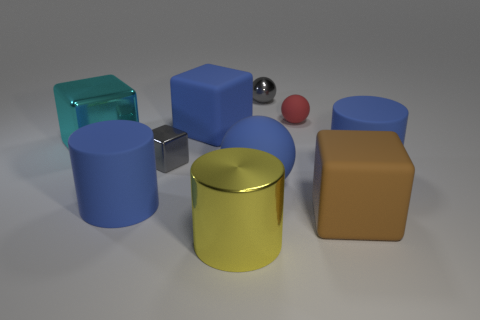Subtract all small gray metallic spheres. How many spheres are left? 2 Subtract all blue balls. How many balls are left? 2 Subtract 2 blocks. How many blocks are left? 2 Subtract all yellow cylinders. How many red balls are left? 1 Subtract all cubes. How many objects are left? 6 Subtract all green cylinders. Subtract all brown blocks. How many cylinders are left? 3 Subtract all cyan shiny blocks. Subtract all cylinders. How many objects are left? 6 Add 3 big blue balls. How many big blue balls are left? 4 Add 5 large blue spheres. How many large blue spheres exist? 6 Subtract 1 blue spheres. How many objects are left? 9 